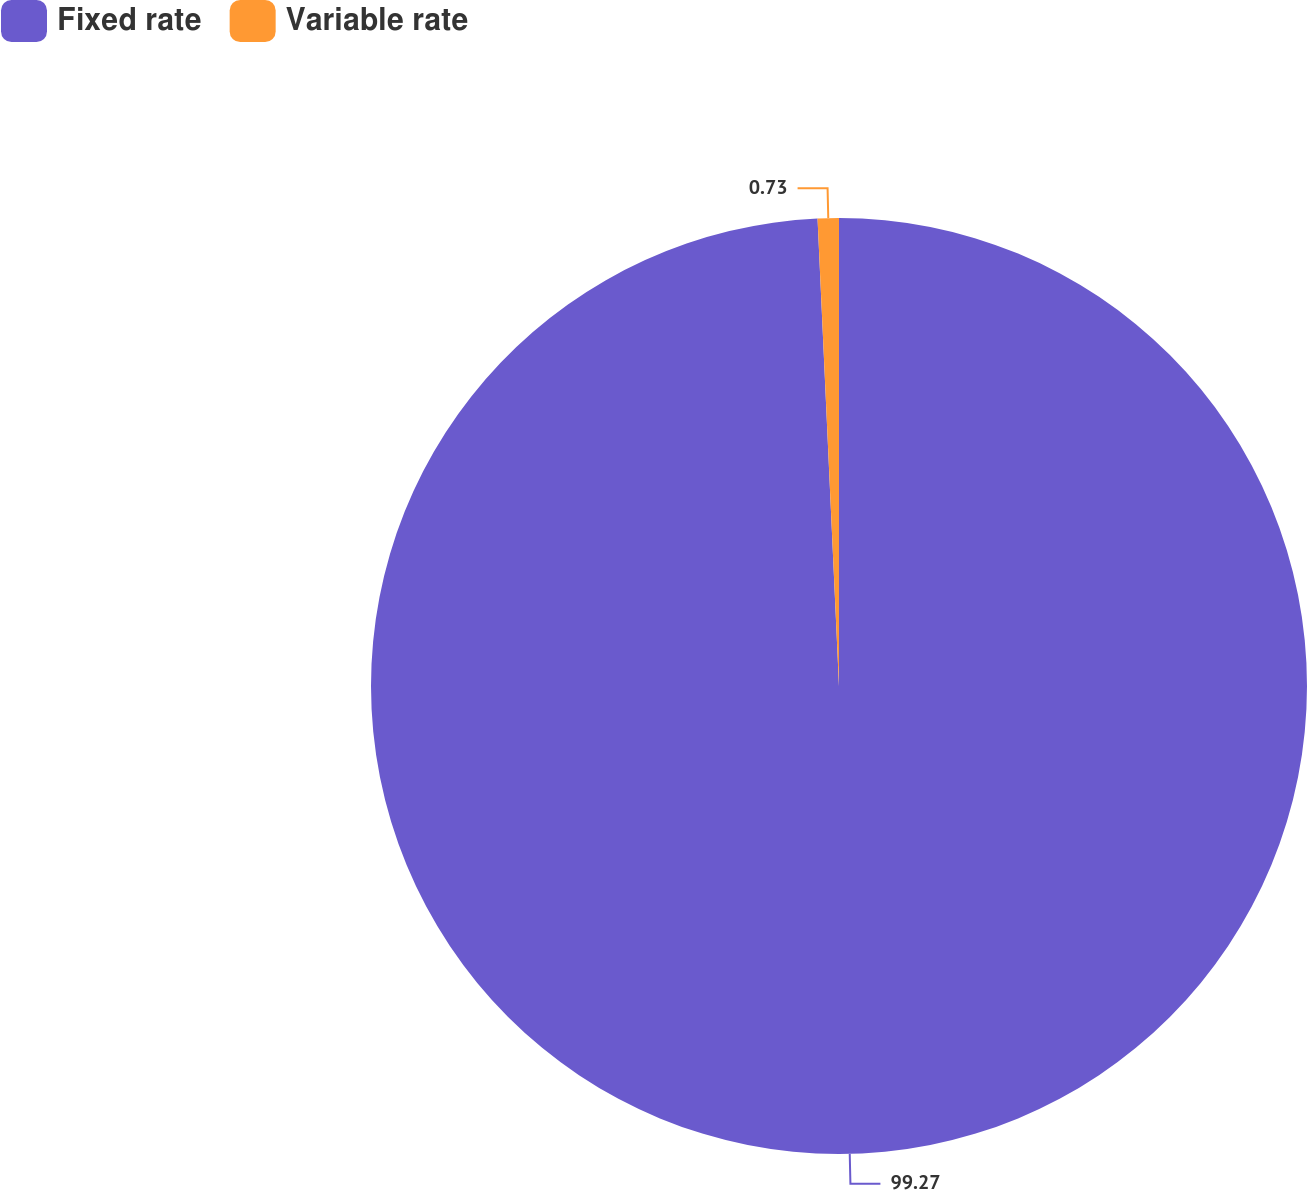Convert chart. <chart><loc_0><loc_0><loc_500><loc_500><pie_chart><fcel>Fixed rate<fcel>Variable rate<nl><fcel>99.27%<fcel>0.73%<nl></chart> 